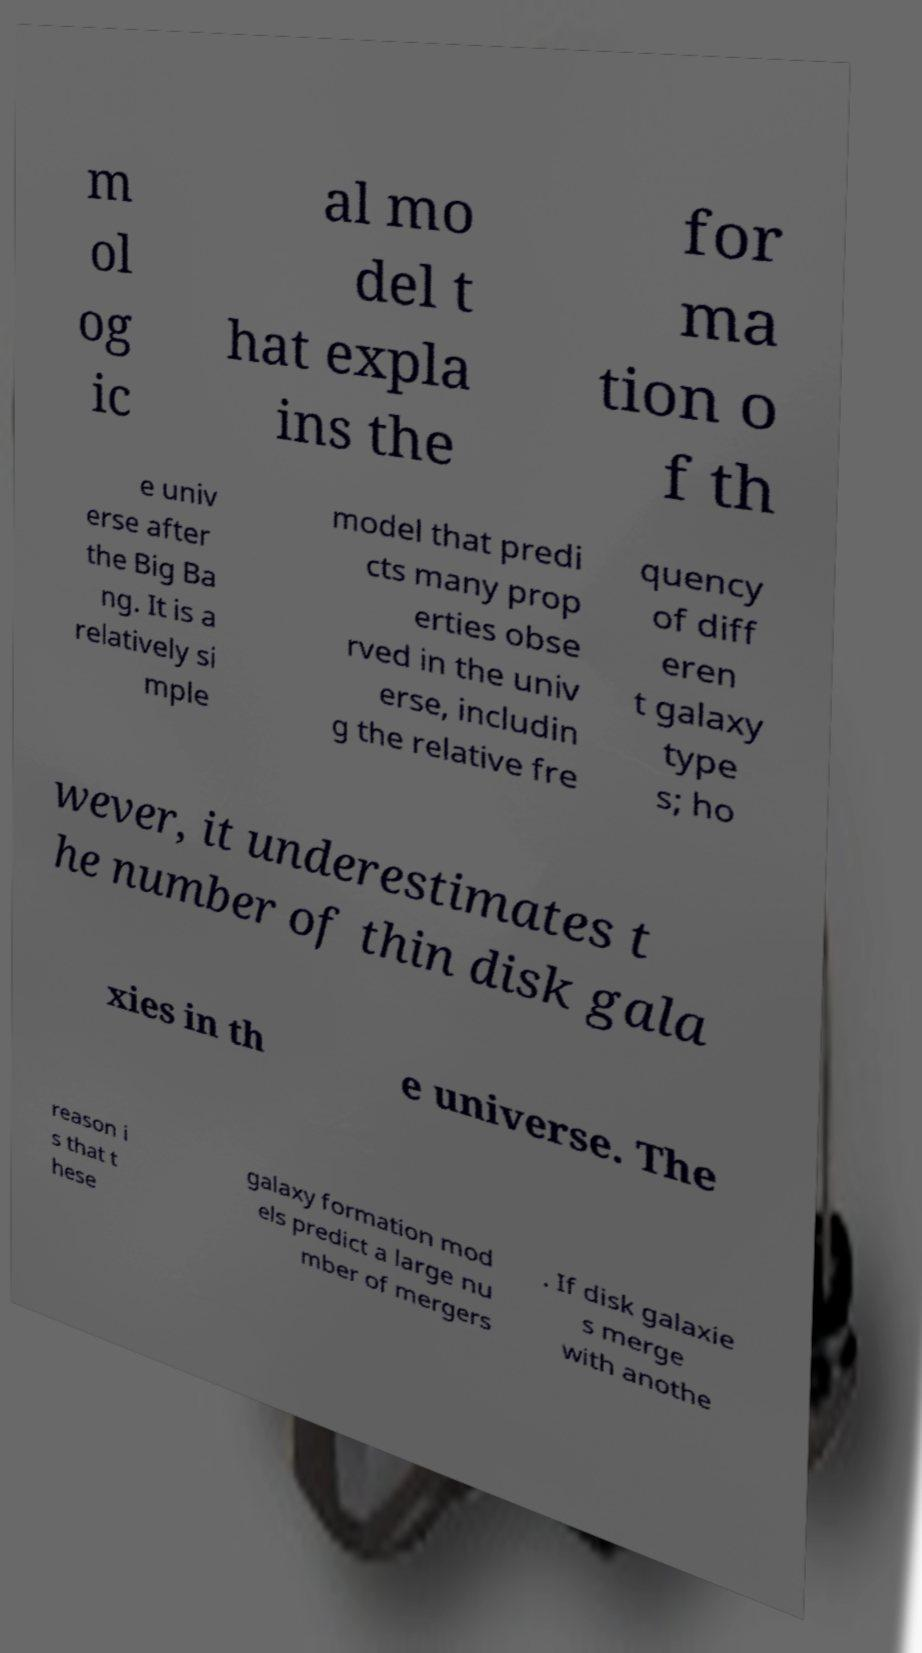What messages or text are displayed in this image? I need them in a readable, typed format. m ol og ic al mo del t hat expla ins the for ma tion o f th e univ erse after the Big Ba ng. It is a relatively si mple model that predi cts many prop erties obse rved in the univ erse, includin g the relative fre quency of diff eren t galaxy type s; ho wever, it underestimates t he number of thin disk gala xies in th e universe. The reason i s that t hese galaxy formation mod els predict a large nu mber of mergers . If disk galaxie s merge with anothe 